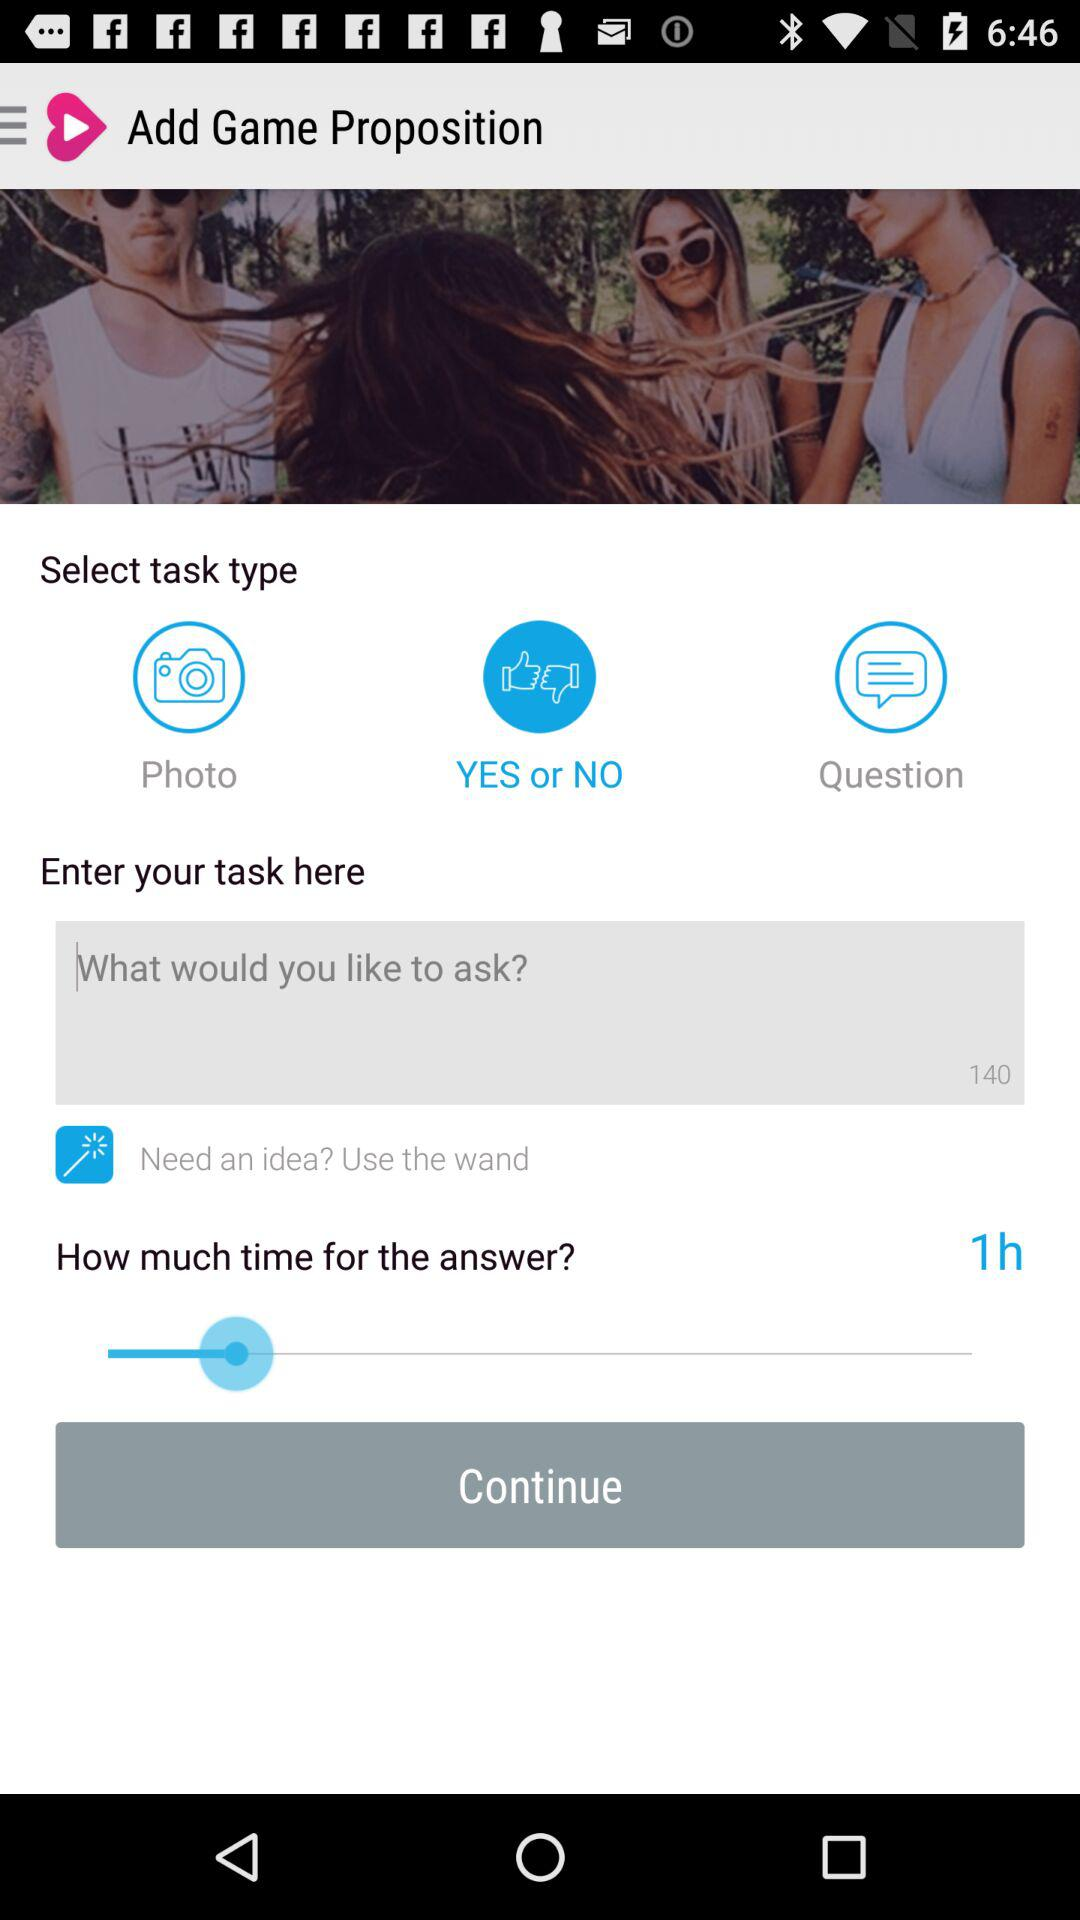How many task types are there?
Answer the question using a single word or phrase. 3 